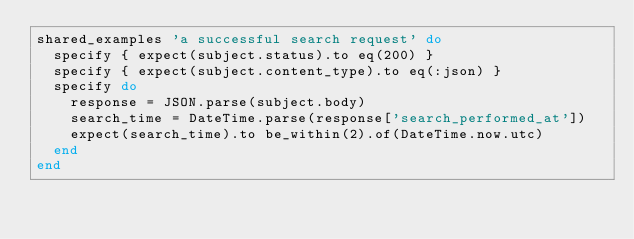Convert code to text. <code><loc_0><loc_0><loc_500><loc_500><_Ruby_>shared_examples 'a successful search request' do
  specify { expect(subject.status).to eq(200) }
  specify { expect(subject.content_type).to eq(:json) }
  specify do
    response = JSON.parse(subject.body)
    search_time = DateTime.parse(response['search_performed_at'])
    expect(search_time).to be_within(2).of(DateTime.now.utc)
  end
end
</code> 